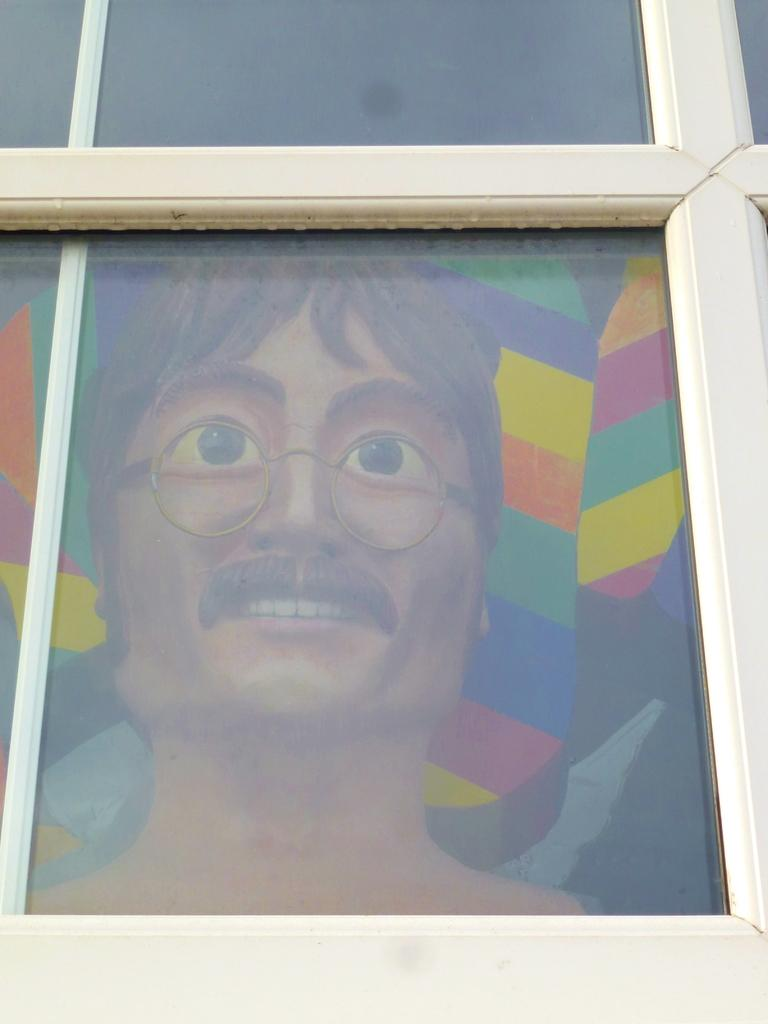What type of material is used for the windows in the image? There are glass windows in the image. Can you describe what is visible behind the windows? A person's face is visible behind the glass window. What type of adjustment can be seen on the brick wall in the image? There is no brick wall present in the image, and therefore no adjustment can be observed. 